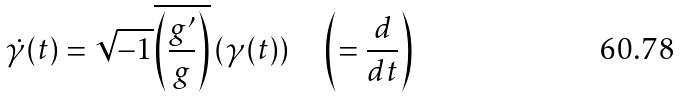<formula> <loc_0><loc_0><loc_500><loc_500>\dot { \gamma } ( t ) = \sqrt { - 1 } \overline { \left ( \frac { g ^ { \prime } } { g } \right ) } \left ( \gamma ( t ) \right ) \quad \left ( = \frac { d } { d t } \right )</formula> 